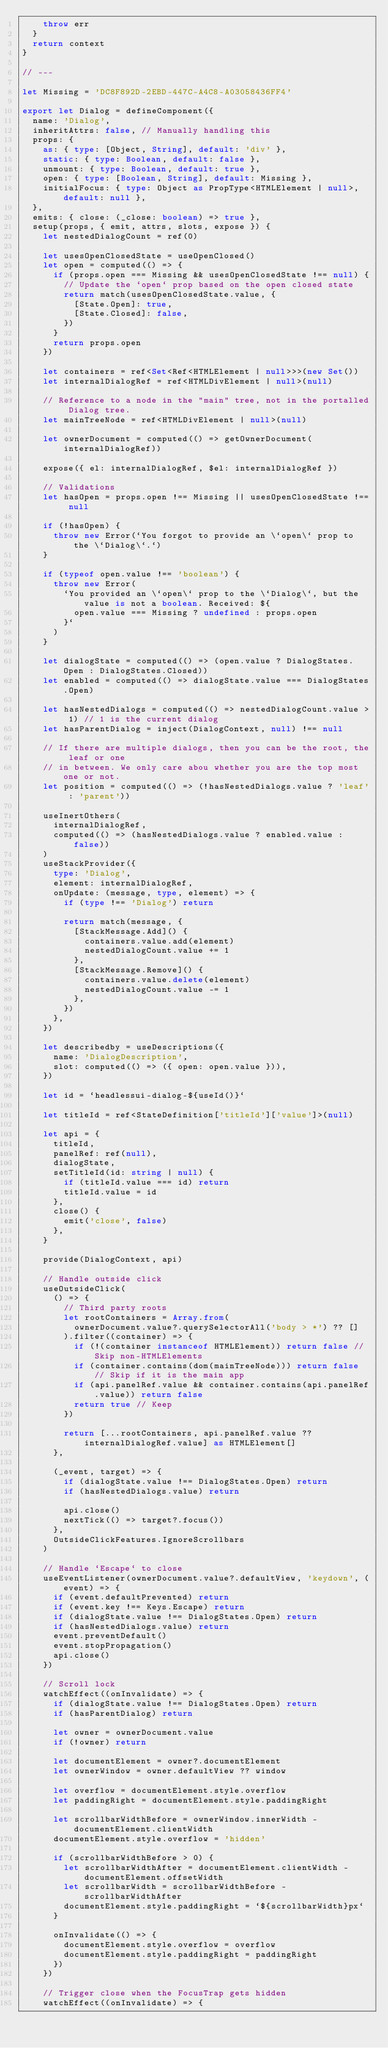<code> <loc_0><loc_0><loc_500><loc_500><_TypeScript_>    throw err
  }
  return context
}

// ---

let Missing = 'DC8F892D-2EBD-447C-A4C8-A03058436FF4'

export let Dialog = defineComponent({
  name: 'Dialog',
  inheritAttrs: false, // Manually handling this
  props: {
    as: { type: [Object, String], default: 'div' },
    static: { type: Boolean, default: false },
    unmount: { type: Boolean, default: true },
    open: { type: [Boolean, String], default: Missing },
    initialFocus: { type: Object as PropType<HTMLElement | null>, default: null },
  },
  emits: { close: (_close: boolean) => true },
  setup(props, { emit, attrs, slots, expose }) {
    let nestedDialogCount = ref(0)

    let usesOpenClosedState = useOpenClosed()
    let open = computed(() => {
      if (props.open === Missing && usesOpenClosedState !== null) {
        // Update the `open` prop based on the open closed state
        return match(usesOpenClosedState.value, {
          [State.Open]: true,
          [State.Closed]: false,
        })
      }
      return props.open
    })

    let containers = ref<Set<Ref<HTMLElement | null>>>(new Set())
    let internalDialogRef = ref<HTMLDivElement | null>(null)

    // Reference to a node in the "main" tree, not in the portalled Dialog tree.
    let mainTreeNode = ref<HTMLDivElement | null>(null)

    let ownerDocument = computed(() => getOwnerDocument(internalDialogRef))

    expose({ el: internalDialogRef, $el: internalDialogRef })

    // Validations
    let hasOpen = props.open !== Missing || usesOpenClosedState !== null

    if (!hasOpen) {
      throw new Error(`You forgot to provide an \`open\` prop to the \`Dialog\`.`)
    }

    if (typeof open.value !== 'boolean') {
      throw new Error(
        `You provided an \`open\` prop to the \`Dialog\`, but the value is not a boolean. Received: ${
          open.value === Missing ? undefined : props.open
        }`
      )
    }

    let dialogState = computed(() => (open.value ? DialogStates.Open : DialogStates.Closed))
    let enabled = computed(() => dialogState.value === DialogStates.Open)

    let hasNestedDialogs = computed(() => nestedDialogCount.value > 1) // 1 is the current dialog
    let hasParentDialog = inject(DialogContext, null) !== null

    // If there are multiple dialogs, then you can be the root, the leaf or one
    // in between. We only care abou whether you are the top most one or not.
    let position = computed(() => (!hasNestedDialogs.value ? 'leaf' : 'parent'))

    useInertOthers(
      internalDialogRef,
      computed(() => (hasNestedDialogs.value ? enabled.value : false))
    )
    useStackProvider({
      type: 'Dialog',
      element: internalDialogRef,
      onUpdate: (message, type, element) => {
        if (type !== 'Dialog') return

        return match(message, {
          [StackMessage.Add]() {
            containers.value.add(element)
            nestedDialogCount.value += 1
          },
          [StackMessage.Remove]() {
            containers.value.delete(element)
            nestedDialogCount.value -= 1
          },
        })
      },
    })

    let describedby = useDescriptions({
      name: 'DialogDescription',
      slot: computed(() => ({ open: open.value })),
    })

    let id = `headlessui-dialog-${useId()}`

    let titleId = ref<StateDefinition['titleId']['value']>(null)

    let api = {
      titleId,
      panelRef: ref(null),
      dialogState,
      setTitleId(id: string | null) {
        if (titleId.value === id) return
        titleId.value = id
      },
      close() {
        emit('close', false)
      },
    }

    provide(DialogContext, api)

    // Handle outside click
    useOutsideClick(
      () => {
        // Third party roots
        let rootContainers = Array.from(
          ownerDocument.value?.querySelectorAll('body > *') ?? []
        ).filter((container) => {
          if (!(container instanceof HTMLElement)) return false // Skip non-HTMLElements
          if (container.contains(dom(mainTreeNode))) return false // Skip if it is the main app
          if (api.panelRef.value && container.contains(api.panelRef.value)) return false
          return true // Keep
        })

        return [...rootContainers, api.panelRef.value ?? internalDialogRef.value] as HTMLElement[]
      },

      (_event, target) => {
        if (dialogState.value !== DialogStates.Open) return
        if (hasNestedDialogs.value) return

        api.close()
        nextTick(() => target?.focus())
      },
      OutsideClickFeatures.IgnoreScrollbars
    )

    // Handle `Escape` to close
    useEventListener(ownerDocument.value?.defaultView, 'keydown', (event) => {
      if (event.defaultPrevented) return
      if (event.key !== Keys.Escape) return
      if (dialogState.value !== DialogStates.Open) return
      if (hasNestedDialogs.value) return
      event.preventDefault()
      event.stopPropagation()
      api.close()
    })

    // Scroll lock
    watchEffect((onInvalidate) => {
      if (dialogState.value !== DialogStates.Open) return
      if (hasParentDialog) return

      let owner = ownerDocument.value
      if (!owner) return

      let documentElement = owner?.documentElement
      let ownerWindow = owner.defaultView ?? window

      let overflow = documentElement.style.overflow
      let paddingRight = documentElement.style.paddingRight

      let scrollbarWidthBefore = ownerWindow.innerWidth - documentElement.clientWidth
      documentElement.style.overflow = 'hidden'

      if (scrollbarWidthBefore > 0) {
        let scrollbarWidthAfter = documentElement.clientWidth - documentElement.offsetWidth
        let scrollbarWidth = scrollbarWidthBefore - scrollbarWidthAfter
        documentElement.style.paddingRight = `${scrollbarWidth}px`
      }

      onInvalidate(() => {
        documentElement.style.overflow = overflow
        documentElement.style.paddingRight = paddingRight
      })
    })

    // Trigger close when the FocusTrap gets hidden
    watchEffect((onInvalidate) => {</code> 